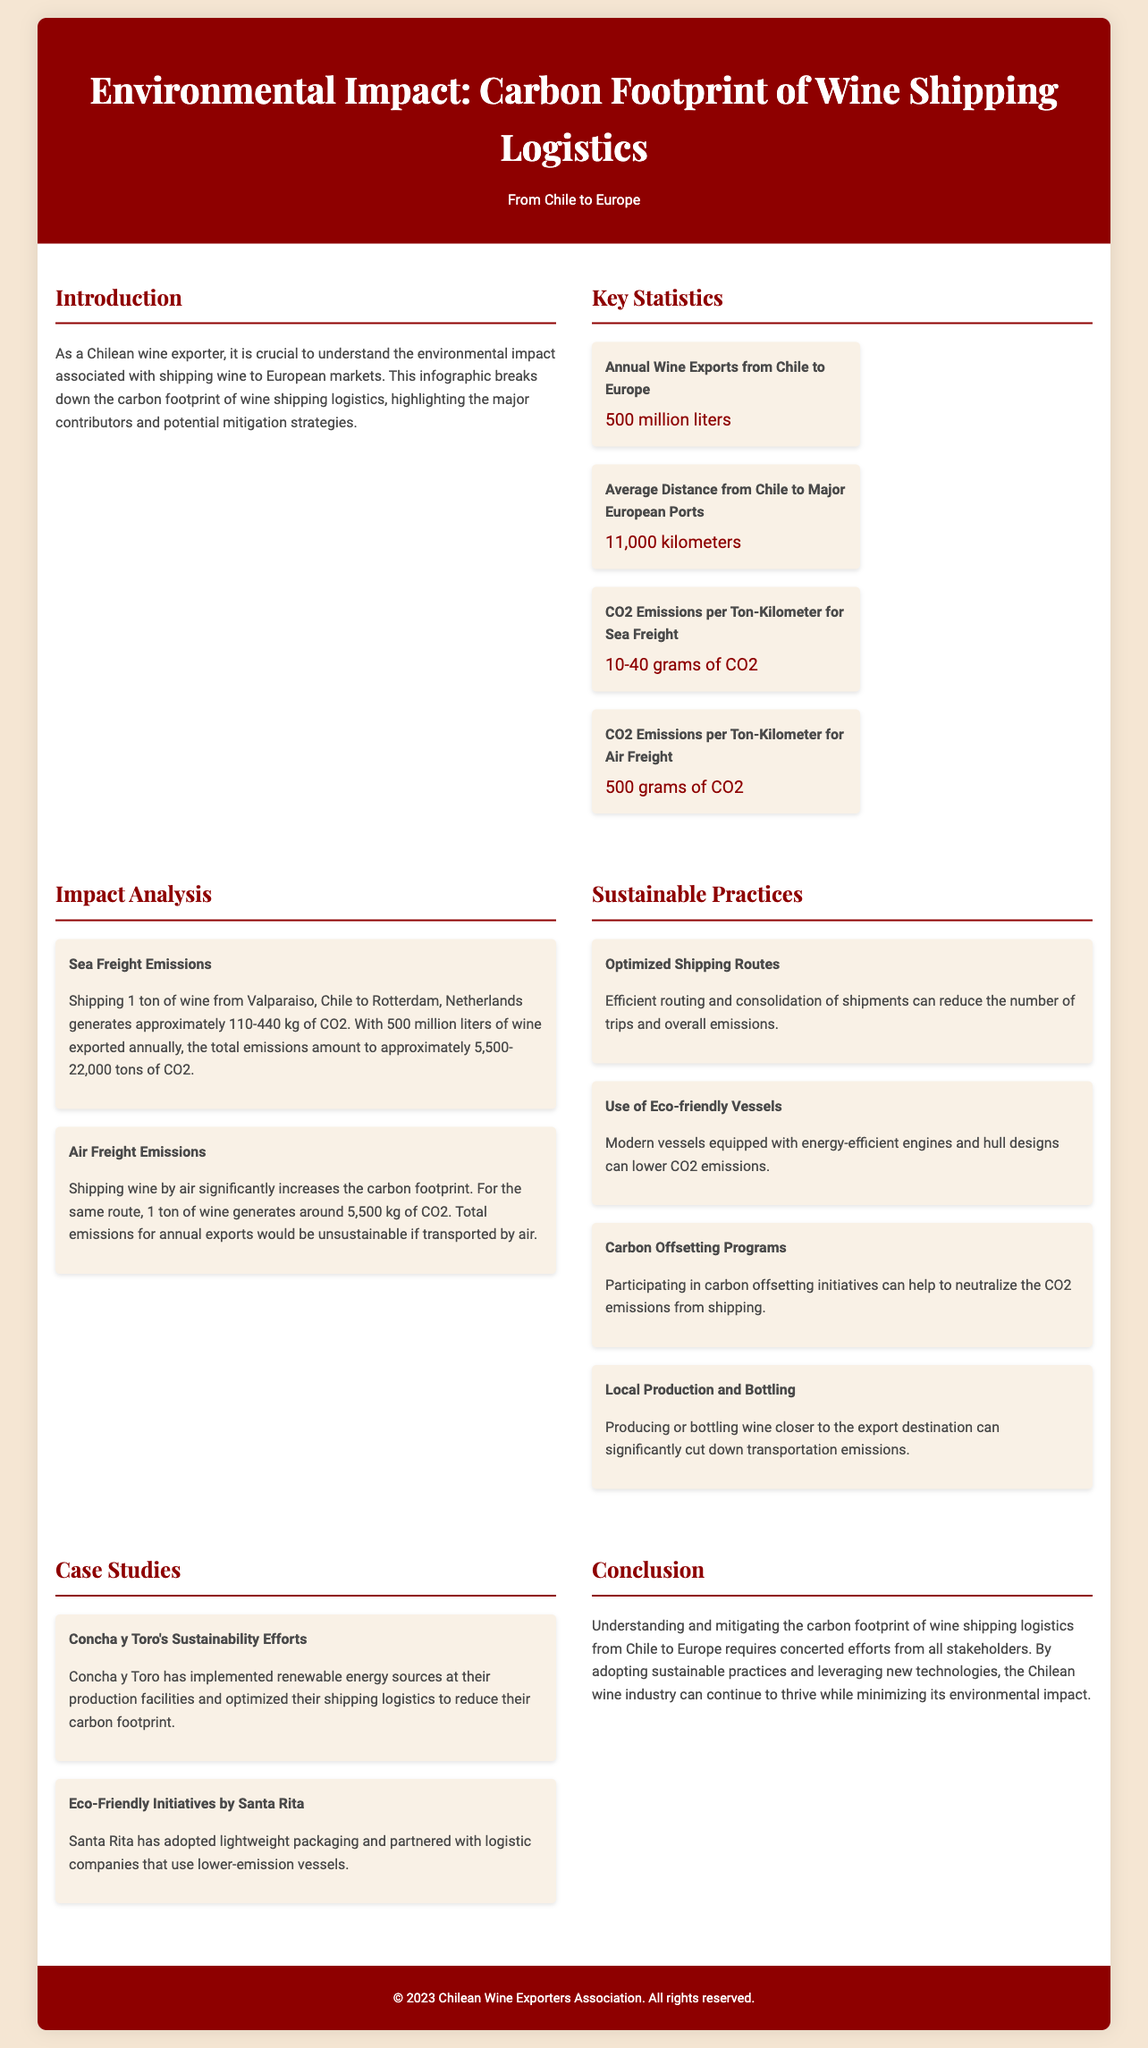what is the annual wine exports from Chile to Europe? The document states that the annual wine exports from Chile to Europe are 500 million liters.
Answer: 500 million liters what is the average distance from Chile to major European ports? According to the document, the average distance from Chile to major European ports is 11,000 kilometers.
Answer: 11,000 kilometers how much CO2 is emitted per ton-kilometer for sea freight? The document indicates that CO2 emissions per ton-kilometer for sea freight range from 10-40 grams of CO2.
Answer: 10-40 grams of CO2 what are the total CO2 emissions from shipping 1 ton of wine by sea from Chile to the Netherlands? The document states that shipping 1 ton of wine generates approximately 110-440 kg of CO2, leading to total emissions of 5,500-22,000 tons annually.
Answer: 5,500-22,000 tons of CO2 what is one sustainable practice mentioned for wine shipping? The document lists several sustainable practices, one of which is optimized shipping routes.
Answer: Optimized shipping routes how much CO2 is generated by air freight for shipping wine? The document mentions that for shipping wine by air, 1 ton generates around 5,500 kg of CO2.
Answer: 5,500 kg of CO2 which company has implemented renewable energy sources in their facilities? The document states that Concha y Toro has implemented renewable energy sources at their production facilities.
Answer: Concha y Toro what is the main conclusion of the document regarding carbon footprint mitigation? The document concludes that understanding and mitigating the carbon footprint requires concerted efforts from all stakeholders.
Answer: Concerted efforts from all stakeholders 